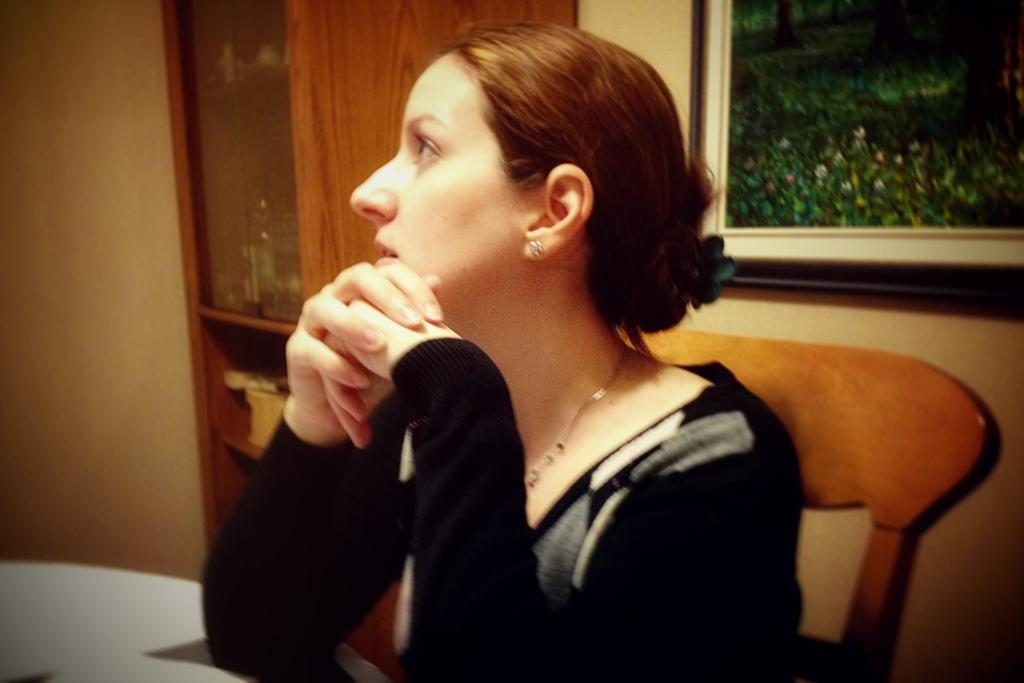What is the woman in the image doing? The woman is sitting on a chair in the image. Can you describe any other furniture or objects in the image? There might be a table in the image, but it is not explicitly mentioned. What is on the wooden rack in the image? The wooden rack has objects on it, but the specific objects are not mentioned. What is attached to the wall in the image? There is a photo frame attached to the wall in the image. What type of drum can be heard playing in the background of the image? There is no drum or sound present in the image; it is a still image. 